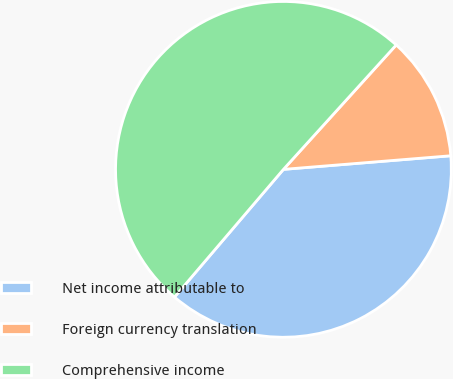Convert chart. <chart><loc_0><loc_0><loc_500><loc_500><pie_chart><fcel>Net income attributable to<fcel>Foreign currency translation<fcel>Comprehensive income<nl><fcel>37.53%<fcel>11.99%<fcel>50.48%<nl></chart> 